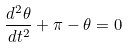<formula> <loc_0><loc_0><loc_500><loc_500>\frac { d ^ { 2 } \theta } { d t ^ { 2 } } + \pi - \theta = 0</formula> 